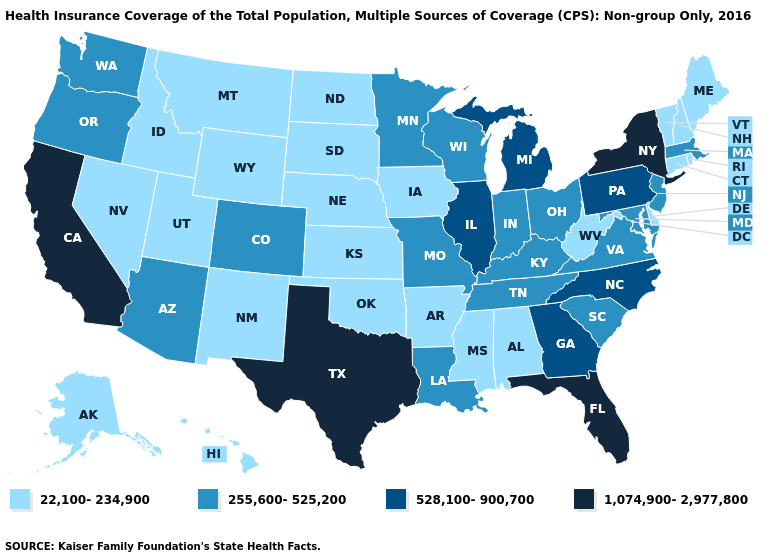Is the legend a continuous bar?
Be succinct. No. What is the highest value in the USA?
Quick response, please. 1,074,900-2,977,800. What is the value of New Mexico?
Quick response, please. 22,100-234,900. What is the value of West Virginia?
Concise answer only. 22,100-234,900. Does Alabama have a lower value than North Carolina?
Short answer required. Yes. Among the states that border New York , which have the highest value?
Be succinct. Pennsylvania. Which states have the highest value in the USA?
Short answer required. California, Florida, New York, Texas. Name the states that have a value in the range 255,600-525,200?
Keep it brief. Arizona, Colorado, Indiana, Kentucky, Louisiana, Maryland, Massachusetts, Minnesota, Missouri, New Jersey, Ohio, Oregon, South Carolina, Tennessee, Virginia, Washington, Wisconsin. What is the value of North Carolina?
Short answer required. 528,100-900,700. What is the value of Wyoming?
Answer briefly. 22,100-234,900. Which states have the highest value in the USA?
Give a very brief answer. California, Florida, New York, Texas. Which states have the lowest value in the USA?
Be succinct. Alabama, Alaska, Arkansas, Connecticut, Delaware, Hawaii, Idaho, Iowa, Kansas, Maine, Mississippi, Montana, Nebraska, Nevada, New Hampshire, New Mexico, North Dakota, Oklahoma, Rhode Island, South Dakota, Utah, Vermont, West Virginia, Wyoming. What is the value of South Carolina?
Be succinct. 255,600-525,200. What is the value of Pennsylvania?
Quick response, please. 528,100-900,700. What is the value of Arkansas?
Short answer required. 22,100-234,900. 